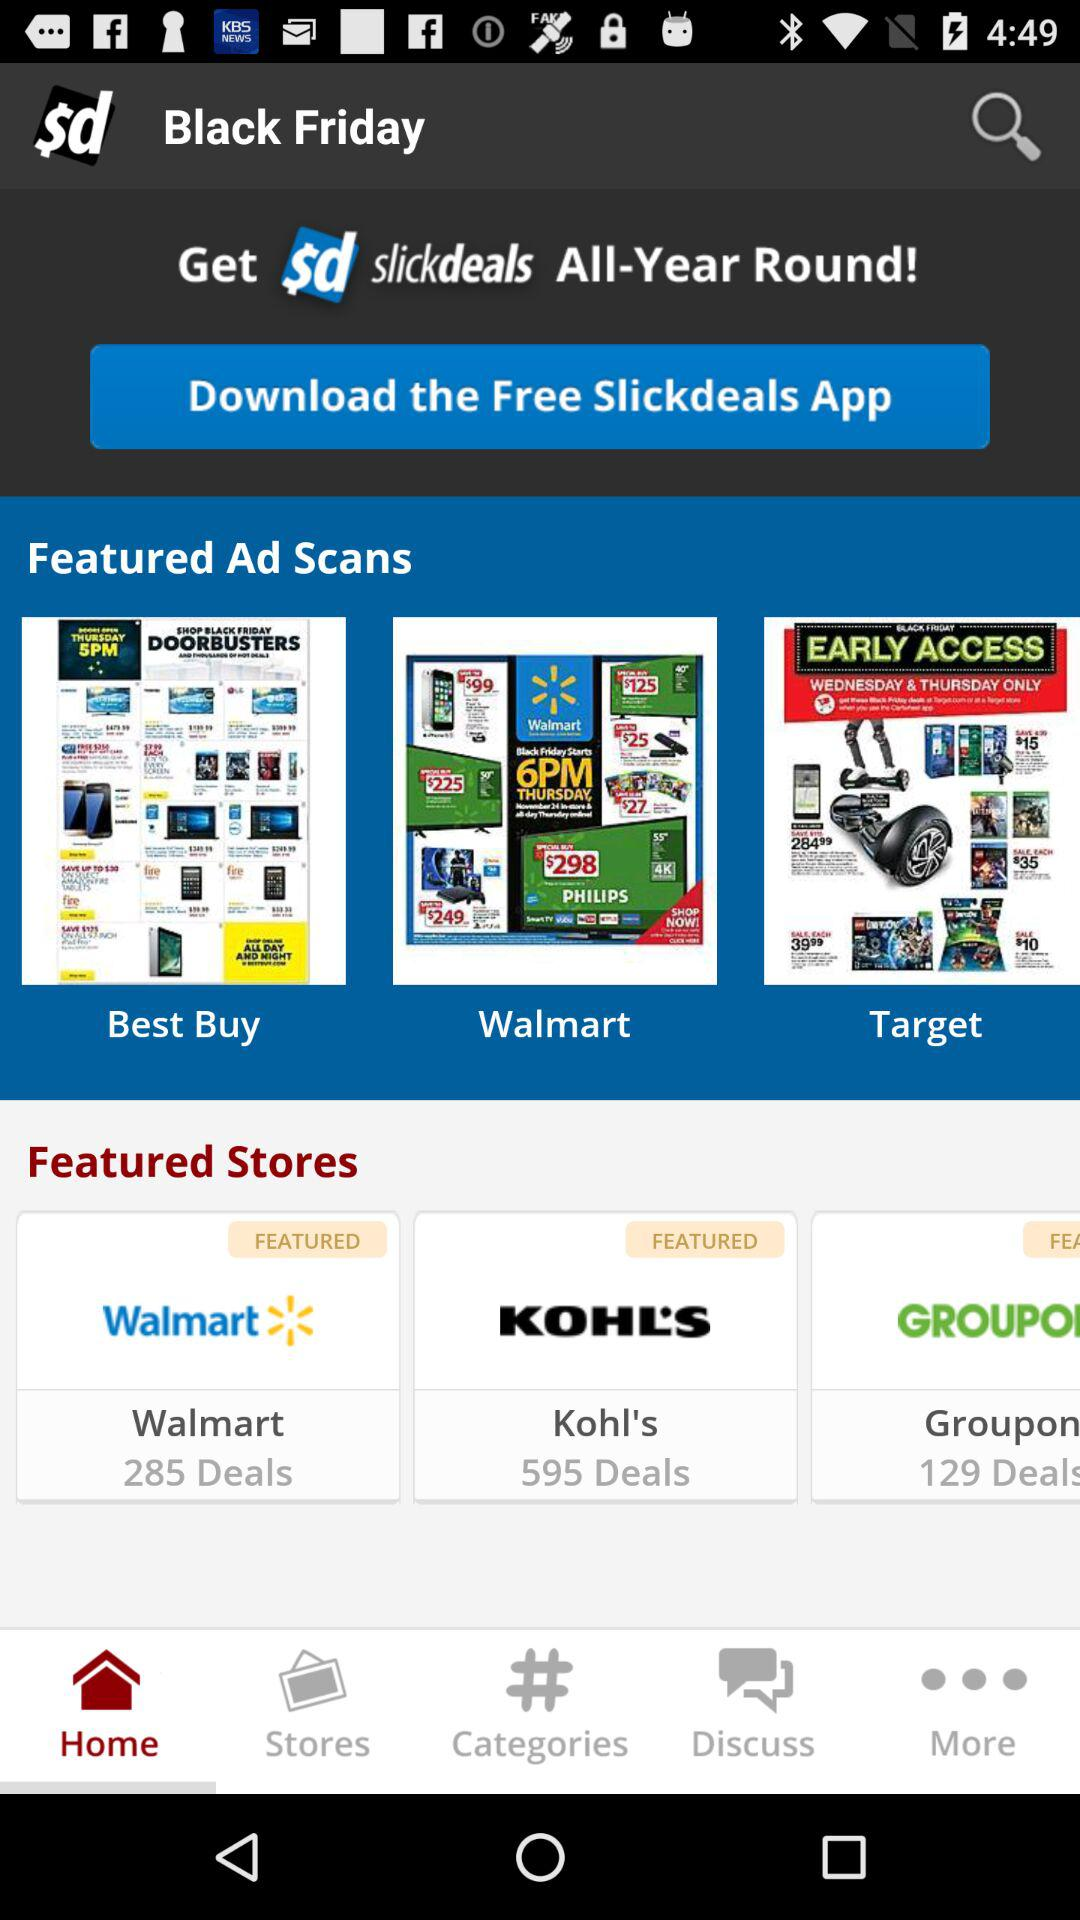What is the total number of "Groupon" deals? The total number of "Groupon" deals is 129. 